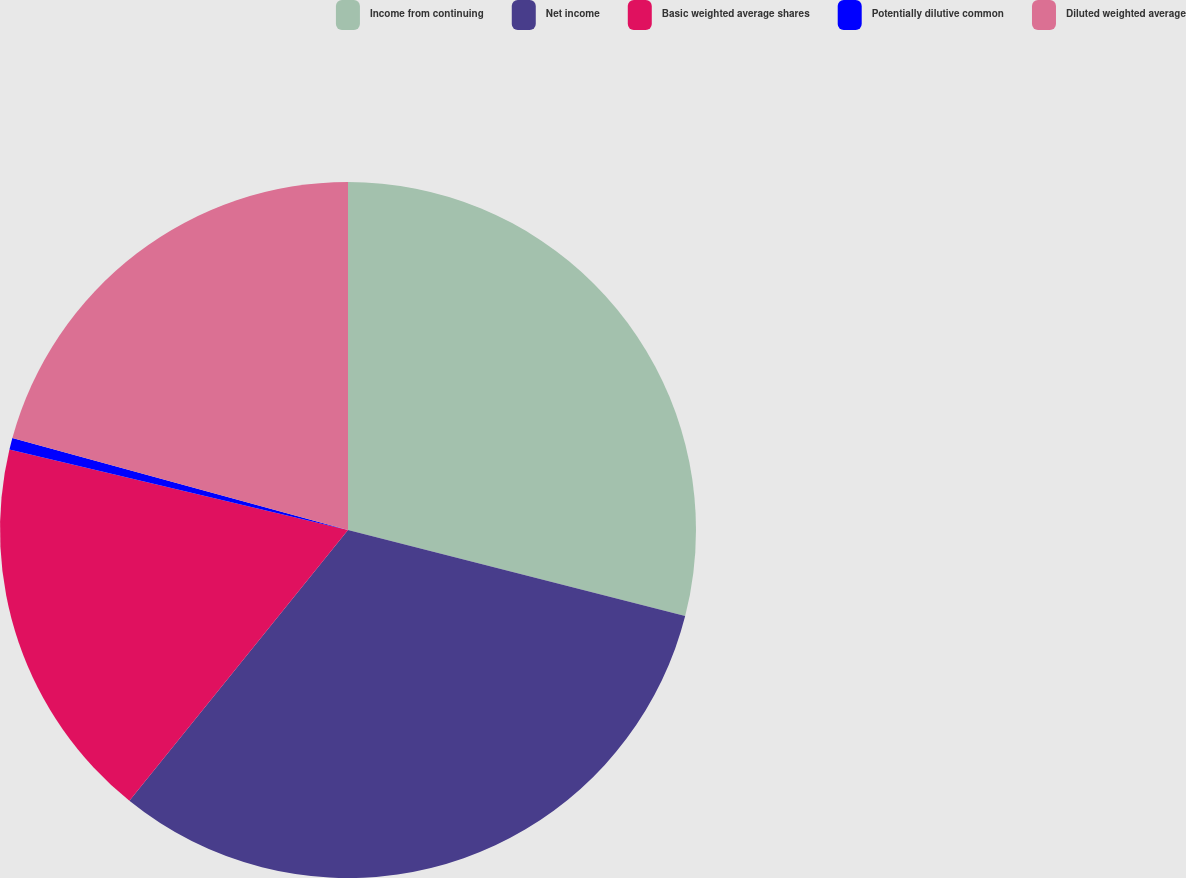Convert chart. <chart><loc_0><loc_0><loc_500><loc_500><pie_chart><fcel>Income from continuing<fcel>Net income<fcel>Basic weighted average shares<fcel>Potentially dilutive common<fcel>Diluted weighted average<nl><fcel>28.98%<fcel>31.83%<fcel>17.9%<fcel>0.55%<fcel>20.74%<nl></chart> 